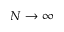<formula> <loc_0><loc_0><loc_500><loc_500>N \rightarrow \infty</formula> 